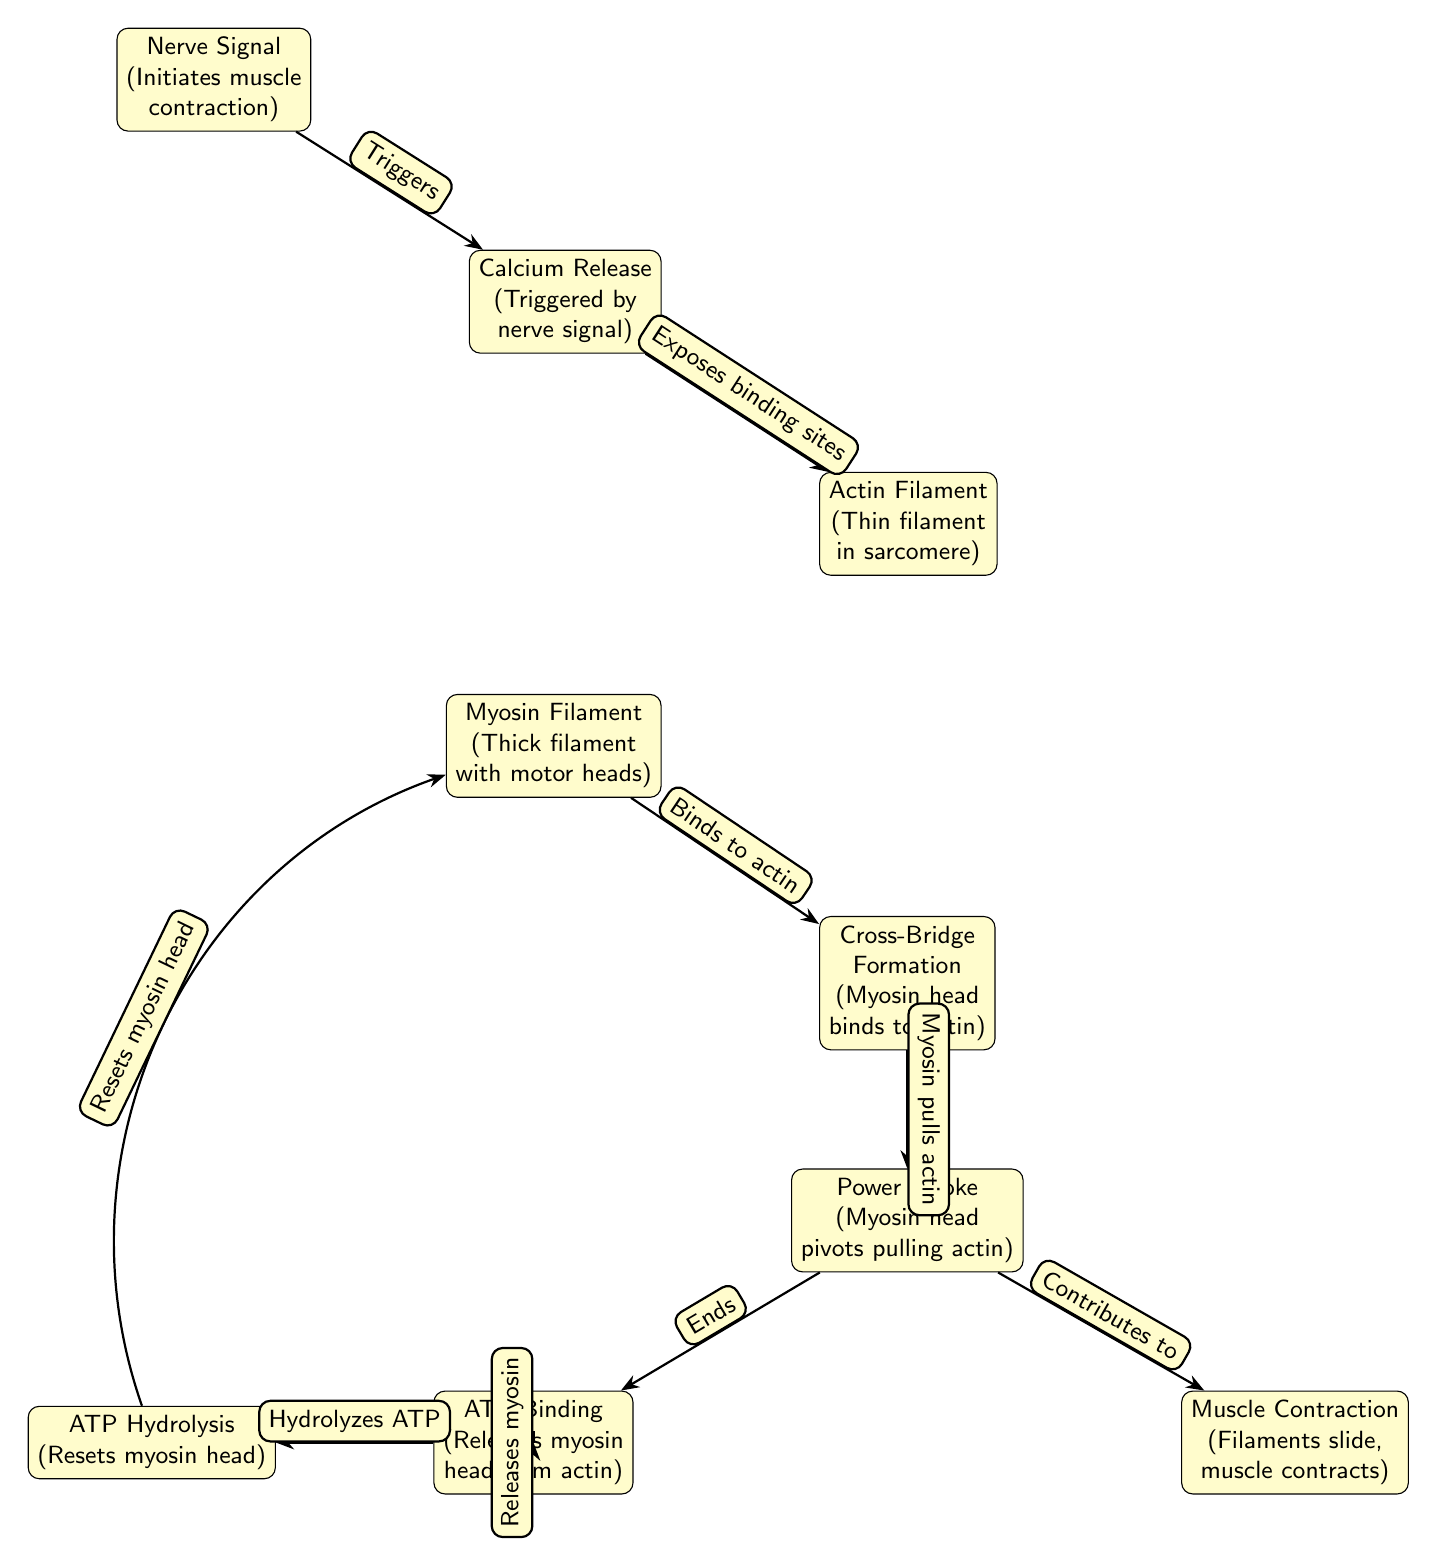What initiates muscle contraction? The diagram indicates that a nerve signal is the first step in the process of muscle contraction, as it is positioned at the top and arrows lead from it to the next components.
Answer: Nerve Signal How many main components are shown in the diagram? By examining the nodes in the diagram, there are a total of 8 main components representing different stages in the muscle contraction process.
Answer: 8 What happens during the Power Stroke phase? The diagram specifies that during the Power Stroke phase, the myosin head pivots and pulls the actin filament, which contributes to muscle contraction. This is noted within the node and the arrow connection to Muscle Contraction.
Answer: Myosin head pivots pulling actin What is released from the myosin head after the Power Stroke? According to the diagram, ATP is released from the myosin head after the Power Stroke, as indicated by the edge labeled "Ends" which connects these two nodes.
Answer: ATP What role does calcium play in muscle contraction? Calcium is shown in the diagram as a necessary component that triggers the release of binding sites on the actin filament, setting off the chain of events for muscle contraction.
Answer: Exposes binding sites Which step resets the myosin head? The diagram shows that ATP Hydrolysis is the step that resets the myosin head, as it is indicated with a direct connection from ATP Binding leading to ATP Hydrolysis.
Answer: ATP Hydrolysis In what part of the process does muscle contraction occur? Muscle contraction is indicated at the end of the process, where the actin and myosin filaments have interacted through previous steps and causes the overall contraction, as noted in the final node.
Answer: Muscle Contraction What connects Myosin Filament and Cross-Bridge Formation? The diagram illustrates that the relationship between Myosin Filament and Cross-Bridge Formation is described by the act of binding to actin, represented by the edge labeled "Binds to actin."
Answer: Binds to actin 